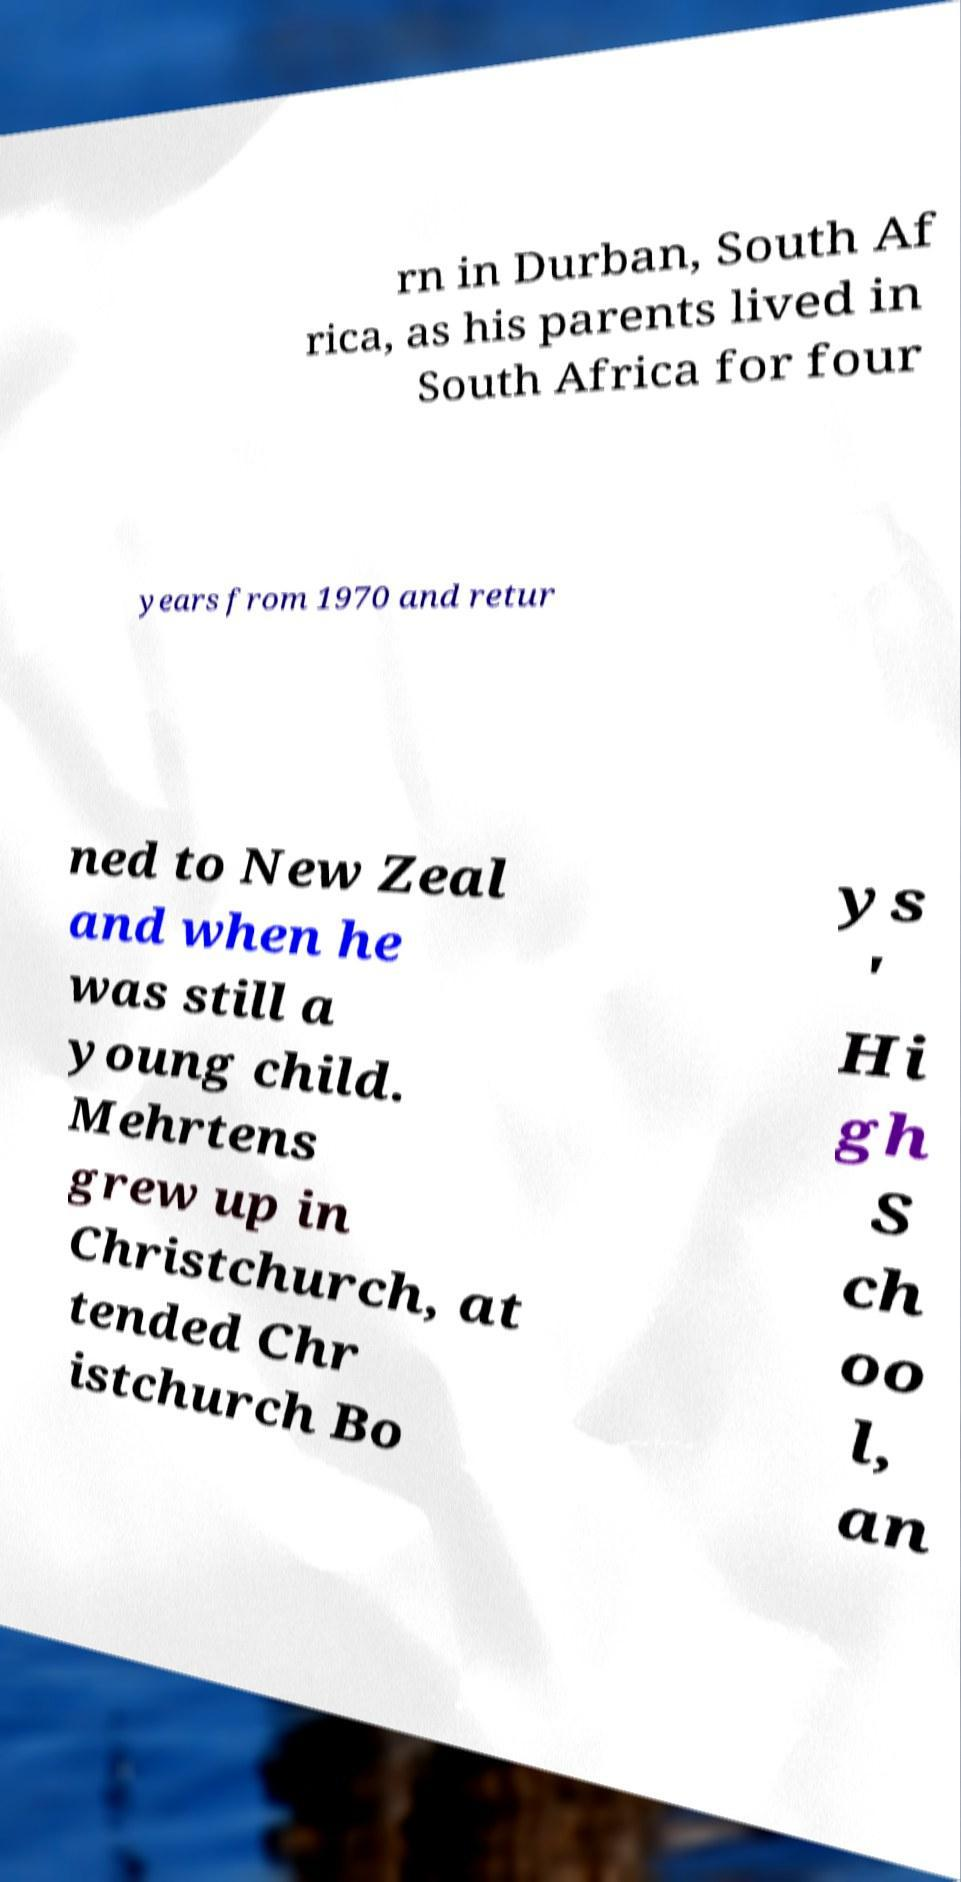Please read and relay the text visible in this image. What does it say? rn in Durban, South Af rica, as his parents lived in South Africa for four years from 1970 and retur ned to New Zeal and when he was still a young child. Mehrtens grew up in Christchurch, at tended Chr istchurch Bo ys ' Hi gh S ch oo l, an 